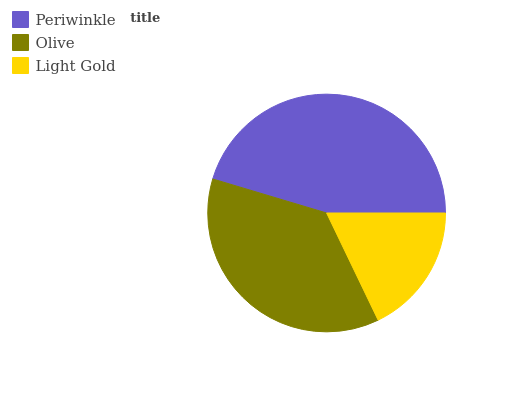Is Light Gold the minimum?
Answer yes or no. Yes. Is Periwinkle the maximum?
Answer yes or no. Yes. Is Olive the minimum?
Answer yes or no. No. Is Olive the maximum?
Answer yes or no. No. Is Periwinkle greater than Olive?
Answer yes or no. Yes. Is Olive less than Periwinkle?
Answer yes or no. Yes. Is Olive greater than Periwinkle?
Answer yes or no. No. Is Periwinkle less than Olive?
Answer yes or no. No. Is Olive the high median?
Answer yes or no. Yes. Is Olive the low median?
Answer yes or no. Yes. Is Periwinkle the high median?
Answer yes or no. No. Is Periwinkle the low median?
Answer yes or no. No. 